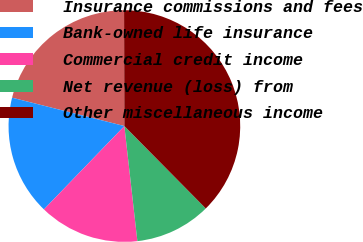Convert chart to OTSL. <chart><loc_0><loc_0><loc_500><loc_500><pie_chart><fcel>Insurance commissions and fees<fcel>Bank-owned life insurance<fcel>Commercial credit income<fcel>Net revenue (loss) from<fcel>Other miscellaneous income<nl><fcel>21.02%<fcel>16.72%<fcel>14.01%<fcel>10.61%<fcel>37.64%<nl></chart> 